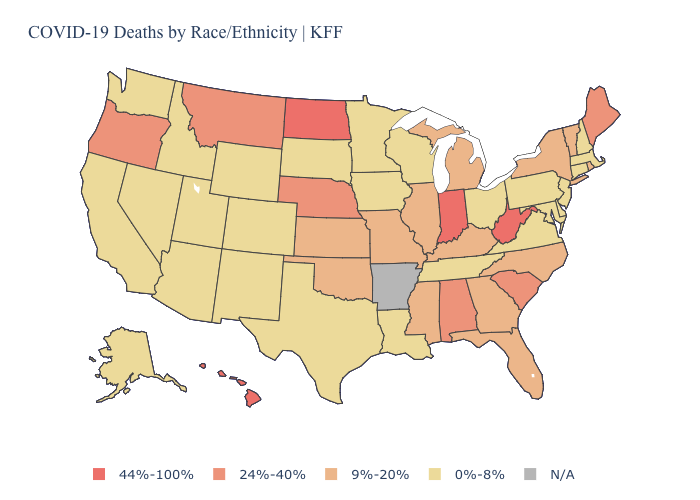Does Delaware have the highest value in the USA?
Answer briefly. No. Is the legend a continuous bar?
Concise answer only. No. What is the highest value in the USA?
Give a very brief answer. 44%-100%. Which states have the lowest value in the USA?
Short answer required. Alaska, Arizona, California, Colorado, Connecticut, Delaware, Idaho, Iowa, Louisiana, Maryland, Massachusetts, Minnesota, Nevada, New Hampshire, New Jersey, New Mexico, Ohio, Pennsylvania, South Dakota, Tennessee, Texas, Utah, Virginia, Washington, Wisconsin, Wyoming. What is the highest value in the USA?
Answer briefly. 44%-100%. What is the highest value in the USA?
Answer briefly. 44%-100%. What is the value of South Dakota?
Answer briefly. 0%-8%. What is the value of Kansas?
Concise answer only. 9%-20%. Among the states that border North Carolina , does Virginia have the lowest value?
Keep it brief. Yes. What is the lowest value in the South?
Short answer required. 0%-8%. Among the states that border Kansas , which have the lowest value?
Give a very brief answer. Colorado. Does Illinois have the lowest value in the USA?
Quick response, please. No. Does Wisconsin have the highest value in the MidWest?
Short answer required. No. What is the highest value in states that border Ohio?
Answer briefly. 44%-100%. 